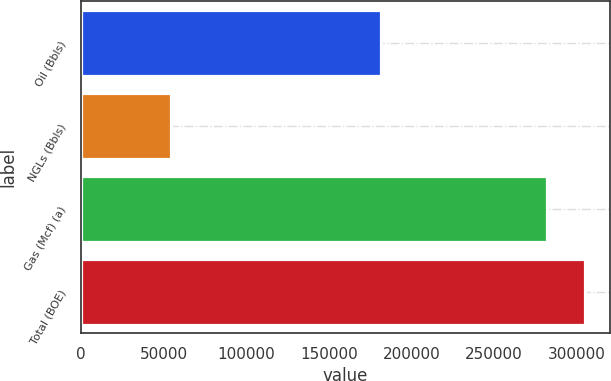Convert chart to OTSL. <chart><loc_0><loc_0><loc_500><loc_500><bar_chart><fcel>Oil (Bbls)<fcel>NGLs (Bbls)<fcel>Gas (Mcf) (a)<fcel>Total (BOE)<nl><fcel>181402<fcel>54459<fcel>282010<fcel>304850<nl></chart> 